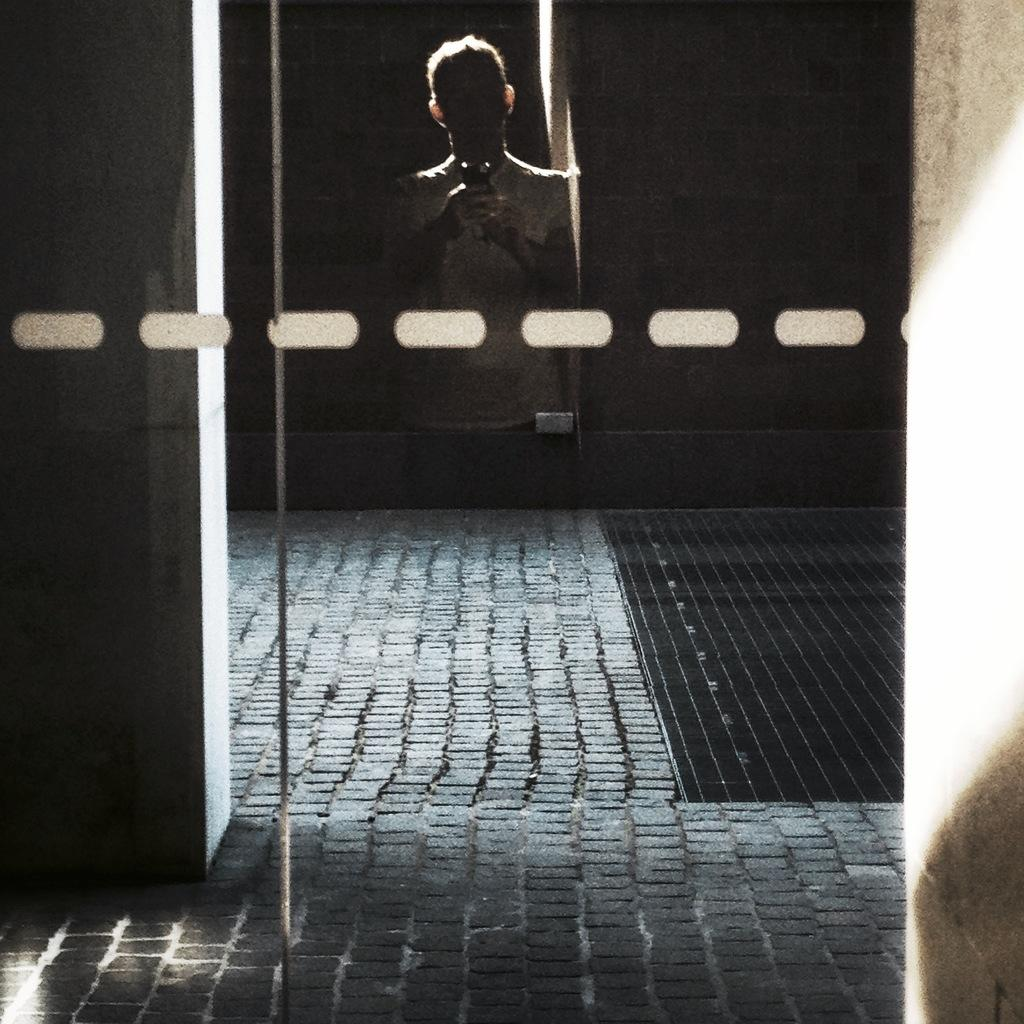What can be seen on the glass in the image? There is a person's reflection on the glass in the image. What is the person doing in the image? The person is taking a picture using a cellphone. What is present in the background of the image? There is a wall in the image, and the background is dark. What type of watch is the person wearing in the image? There is no watch visible in the image; only the person's reflection on the glass and their action of taking a picture using a cellphone can be seen. 